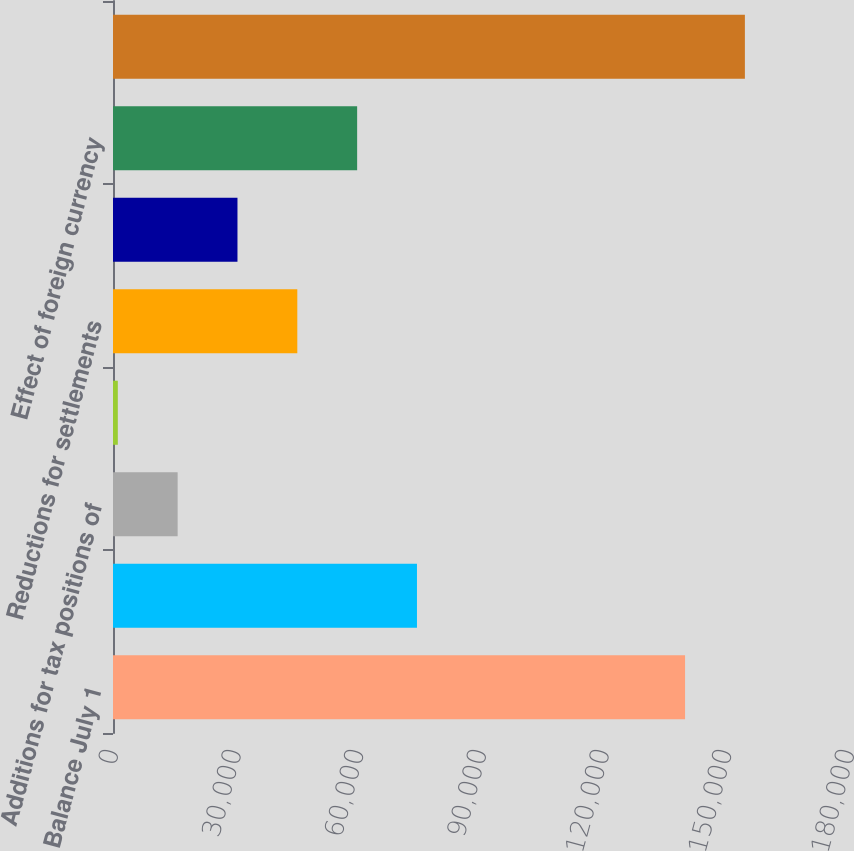<chart> <loc_0><loc_0><loc_500><loc_500><bar_chart><fcel>Balance July 1<fcel>Additions for tax positions<fcel>Additions for tax positions of<fcel>Reductions for tax positions<fcel>Reductions for settlements<fcel>Reductions for expiration of<fcel>Effect of foreign currency<fcel>Balance June 30<nl><fcel>139907<fcel>74340.5<fcel>15808.1<fcel>1175<fcel>45074.3<fcel>30441.2<fcel>59707.4<fcel>154540<nl></chart> 